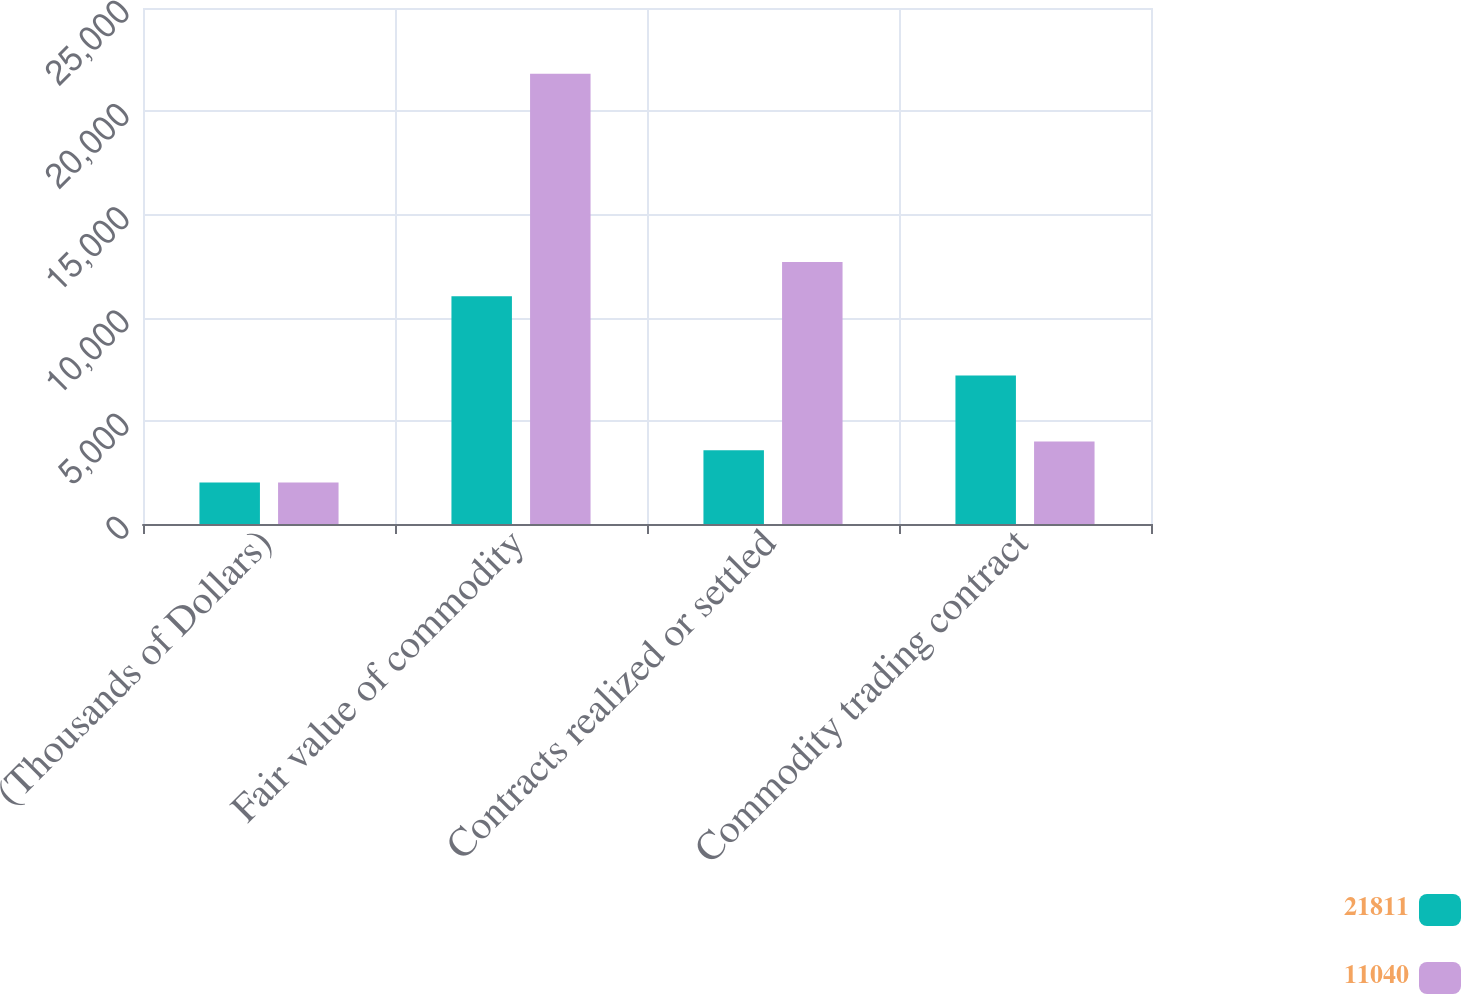<chart> <loc_0><loc_0><loc_500><loc_500><stacked_bar_chart><ecel><fcel>(Thousands of Dollars)<fcel>Fair value of commodity<fcel>Contracts realized or settled<fcel>Commodity trading contract<nl><fcel>21811<fcel>2015<fcel>11040<fcel>3578<fcel>7193<nl><fcel>11040<fcel>2014<fcel>21811<fcel>12698<fcel>3995<nl></chart> 